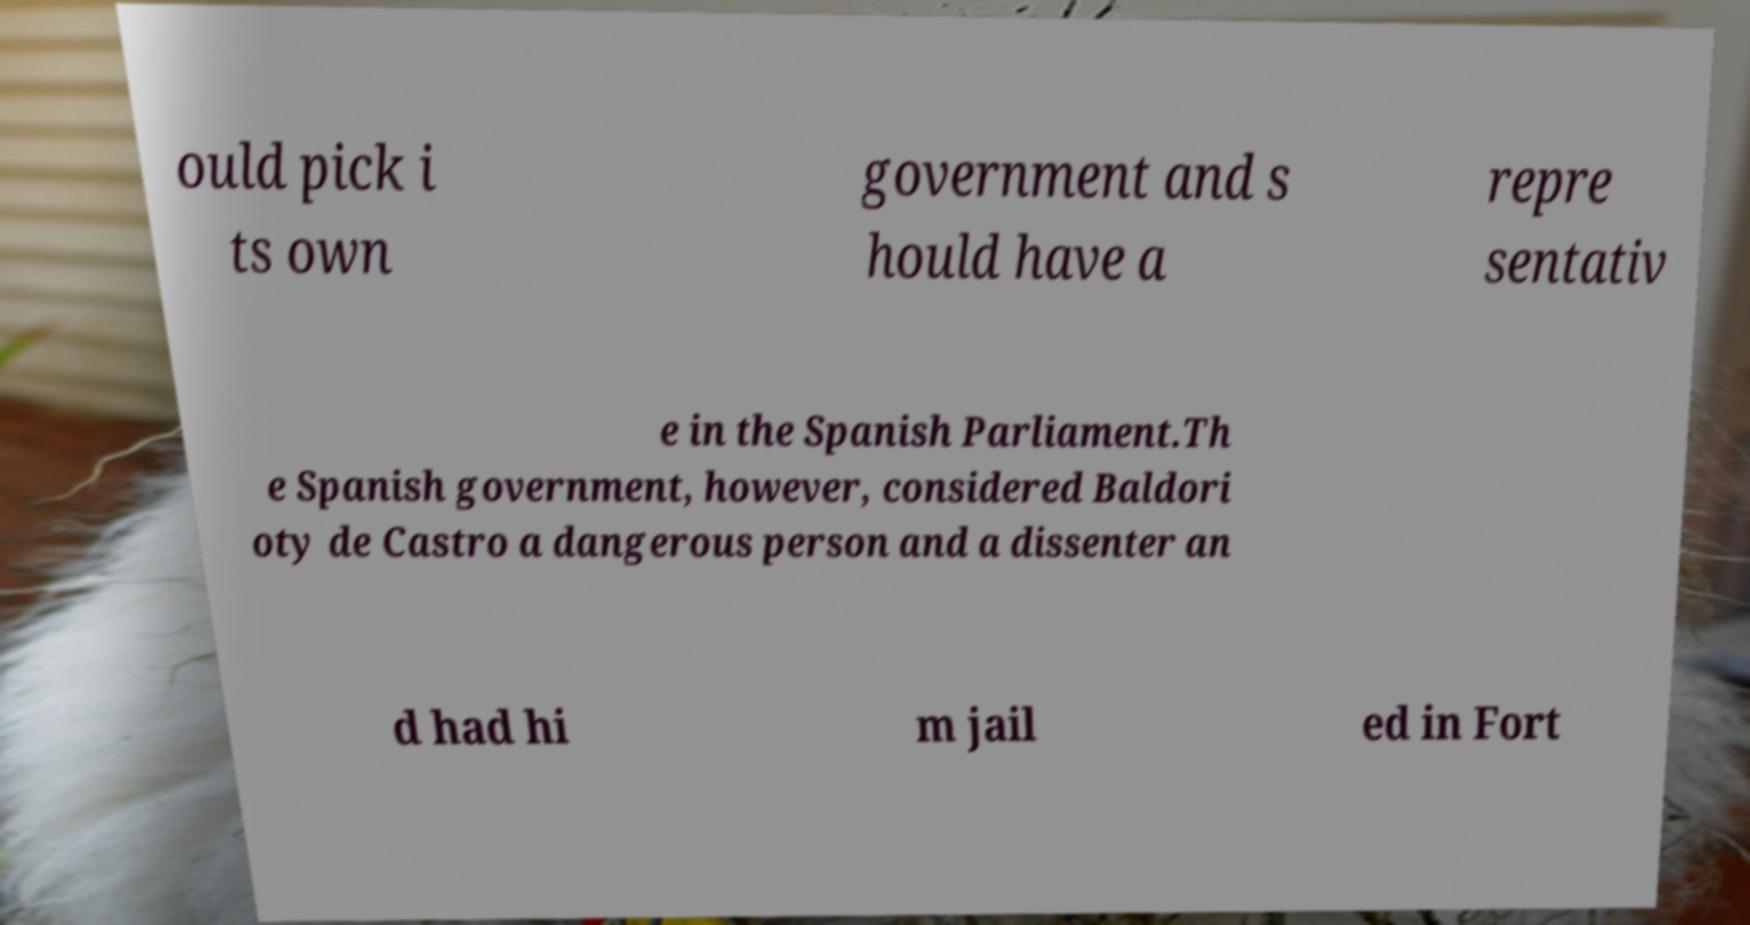I need the written content from this picture converted into text. Can you do that? ould pick i ts own government and s hould have a repre sentativ e in the Spanish Parliament.Th e Spanish government, however, considered Baldori oty de Castro a dangerous person and a dissenter an d had hi m jail ed in Fort 